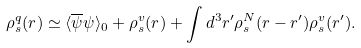Convert formula to latex. <formula><loc_0><loc_0><loc_500><loc_500>\rho _ { s } ^ { q } ( r ) \simeq \langle \overline { \psi } \psi \rangle _ { 0 } + \rho _ { s } ^ { v } ( r ) + \int d ^ { 3 } r ^ { \prime } \rho _ { s } ^ { N } ( r - r ^ { \prime } ) \rho _ { s } ^ { v } ( r ^ { \prime } ) .</formula> 